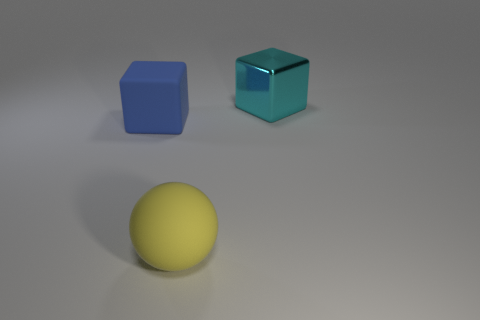Add 3 big cyan things. How many objects exist? 6 Subtract all cubes. How many objects are left? 1 Add 3 yellow rubber spheres. How many yellow rubber spheres are left? 4 Add 2 spheres. How many spheres exist? 3 Subtract 0 gray spheres. How many objects are left? 3 Subtract all cyan blocks. Subtract all yellow spheres. How many blocks are left? 1 Subtract all red matte objects. Subtract all blue things. How many objects are left? 2 